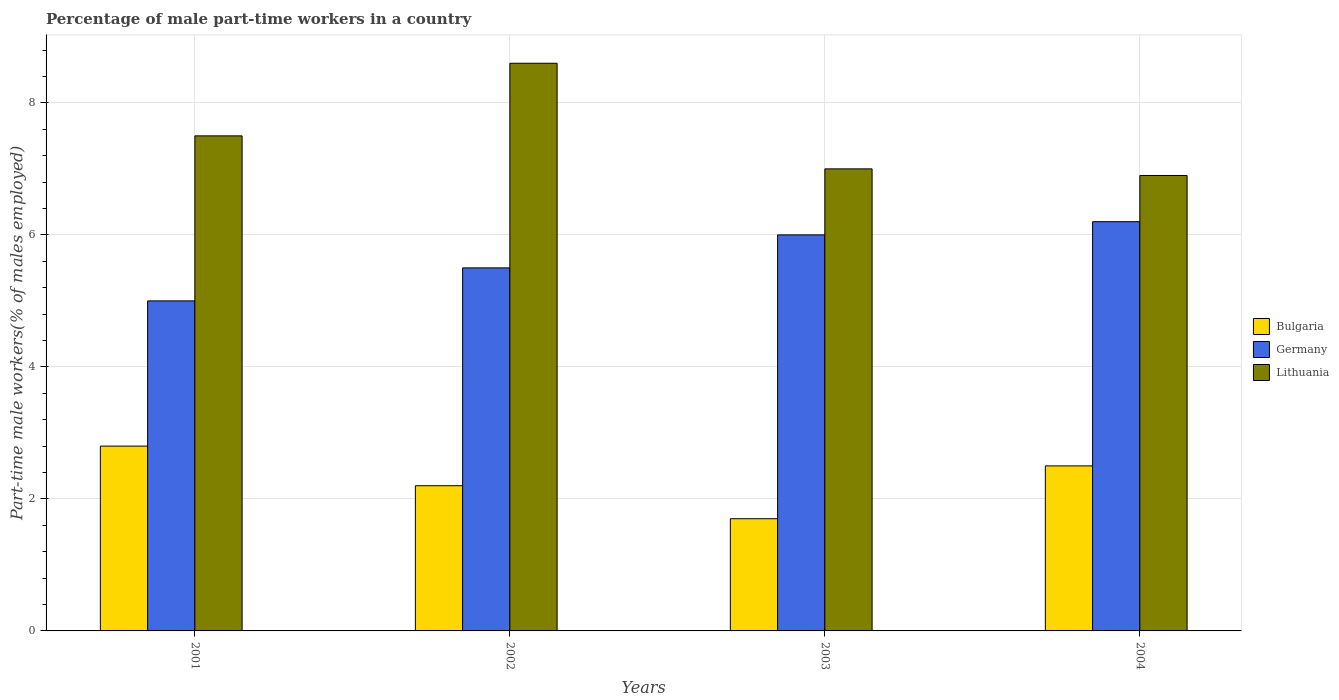How many different coloured bars are there?
Your answer should be very brief. 3. How many groups of bars are there?
Keep it short and to the point. 4. Are the number of bars per tick equal to the number of legend labels?
Give a very brief answer. Yes. Are the number of bars on each tick of the X-axis equal?
Offer a very short reply. Yes. How many bars are there on the 3rd tick from the left?
Make the answer very short. 3. In how many cases, is the number of bars for a given year not equal to the number of legend labels?
Your answer should be compact. 0. What is the percentage of male part-time workers in Bulgaria in 2002?
Make the answer very short. 2.2. Across all years, what is the maximum percentage of male part-time workers in Germany?
Your answer should be compact. 6.2. Across all years, what is the minimum percentage of male part-time workers in Lithuania?
Provide a succinct answer. 6.9. In which year was the percentage of male part-time workers in Germany maximum?
Your answer should be compact. 2004. In which year was the percentage of male part-time workers in Bulgaria minimum?
Offer a very short reply. 2003. What is the total percentage of male part-time workers in Germany in the graph?
Your answer should be compact. 22.7. What is the difference between the percentage of male part-time workers in Germany in 2003 and that in 2004?
Ensure brevity in your answer.  -0.2. What is the difference between the percentage of male part-time workers in Lithuania in 2002 and the percentage of male part-time workers in Germany in 2004?
Provide a short and direct response. 2.4. What is the average percentage of male part-time workers in Lithuania per year?
Your answer should be compact. 7.5. In the year 2003, what is the difference between the percentage of male part-time workers in Lithuania and percentage of male part-time workers in Bulgaria?
Provide a short and direct response. 5.3. In how many years, is the percentage of male part-time workers in Lithuania greater than 2.8 %?
Provide a short and direct response. 4. What is the ratio of the percentage of male part-time workers in Lithuania in 2001 to that in 2004?
Ensure brevity in your answer.  1.09. Is the difference between the percentage of male part-time workers in Lithuania in 2001 and 2004 greater than the difference between the percentage of male part-time workers in Bulgaria in 2001 and 2004?
Your response must be concise. Yes. What is the difference between the highest and the second highest percentage of male part-time workers in Bulgaria?
Make the answer very short. 0.3. What is the difference between the highest and the lowest percentage of male part-time workers in Lithuania?
Make the answer very short. 1.7. Is the sum of the percentage of male part-time workers in Lithuania in 2001 and 2004 greater than the maximum percentage of male part-time workers in Bulgaria across all years?
Make the answer very short. Yes. What does the 3rd bar from the left in 2002 represents?
Your answer should be very brief. Lithuania. What does the 1st bar from the right in 2001 represents?
Make the answer very short. Lithuania. Is it the case that in every year, the sum of the percentage of male part-time workers in Bulgaria and percentage of male part-time workers in Germany is greater than the percentage of male part-time workers in Lithuania?
Offer a terse response. No. How many bars are there?
Your answer should be very brief. 12. Are all the bars in the graph horizontal?
Give a very brief answer. No. How many years are there in the graph?
Your answer should be very brief. 4. What is the difference between two consecutive major ticks on the Y-axis?
Your answer should be compact. 2. Are the values on the major ticks of Y-axis written in scientific E-notation?
Offer a very short reply. No. Does the graph contain any zero values?
Ensure brevity in your answer.  No. What is the title of the graph?
Your answer should be very brief. Percentage of male part-time workers in a country. What is the label or title of the Y-axis?
Make the answer very short. Part-time male workers(% of males employed). What is the Part-time male workers(% of males employed) of Bulgaria in 2001?
Your answer should be compact. 2.8. What is the Part-time male workers(% of males employed) in Bulgaria in 2002?
Provide a succinct answer. 2.2. What is the Part-time male workers(% of males employed) of Germany in 2002?
Provide a succinct answer. 5.5. What is the Part-time male workers(% of males employed) in Lithuania in 2002?
Keep it short and to the point. 8.6. What is the Part-time male workers(% of males employed) in Bulgaria in 2003?
Your answer should be compact. 1.7. What is the Part-time male workers(% of males employed) in Germany in 2003?
Offer a terse response. 6. What is the Part-time male workers(% of males employed) of Germany in 2004?
Your answer should be very brief. 6.2. What is the Part-time male workers(% of males employed) of Lithuania in 2004?
Ensure brevity in your answer.  6.9. Across all years, what is the maximum Part-time male workers(% of males employed) of Bulgaria?
Offer a very short reply. 2.8. Across all years, what is the maximum Part-time male workers(% of males employed) of Germany?
Offer a very short reply. 6.2. Across all years, what is the maximum Part-time male workers(% of males employed) of Lithuania?
Your response must be concise. 8.6. Across all years, what is the minimum Part-time male workers(% of males employed) of Bulgaria?
Your answer should be compact. 1.7. Across all years, what is the minimum Part-time male workers(% of males employed) in Lithuania?
Your response must be concise. 6.9. What is the total Part-time male workers(% of males employed) of Germany in the graph?
Keep it short and to the point. 22.7. What is the total Part-time male workers(% of males employed) of Lithuania in the graph?
Keep it short and to the point. 30. What is the difference between the Part-time male workers(% of males employed) of Germany in 2001 and that in 2002?
Your answer should be compact. -0.5. What is the difference between the Part-time male workers(% of males employed) of Lithuania in 2001 and that in 2002?
Keep it short and to the point. -1.1. What is the difference between the Part-time male workers(% of males employed) of Germany in 2001 and that in 2003?
Ensure brevity in your answer.  -1. What is the difference between the Part-time male workers(% of males employed) in Lithuania in 2001 and that in 2003?
Make the answer very short. 0.5. What is the difference between the Part-time male workers(% of males employed) in Germany in 2001 and that in 2004?
Give a very brief answer. -1.2. What is the difference between the Part-time male workers(% of males employed) in Lithuania in 2002 and that in 2004?
Keep it short and to the point. 1.7. What is the difference between the Part-time male workers(% of males employed) of Germany in 2003 and that in 2004?
Offer a terse response. -0.2. What is the difference between the Part-time male workers(% of males employed) of Lithuania in 2003 and that in 2004?
Give a very brief answer. 0.1. What is the difference between the Part-time male workers(% of males employed) in Bulgaria in 2001 and the Part-time male workers(% of males employed) in Lithuania in 2002?
Ensure brevity in your answer.  -5.8. What is the difference between the Part-time male workers(% of males employed) in Germany in 2001 and the Part-time male workers(% of males employed) in Lithuania in 2002?
Give a very brief answer. -3.6. What is the difference between the Part-time male workers(% of males employed) in Bulgaria in 2001 and the Part-time male workers(% of males employed) in Germany in 2003?
Make the answer very short. -3.2. What is the difference between the Part-time male workers(% of males employed) in Germany in 2001 and the Part-time male workers(% of males employed) in Lithuania in 2003?
Make the answer very short. -2. What is the difference between the Part-time male workers(% of males employed) of Bulgaria in 2001 and the Part-time male workers(% of males employed) of Germany in 2004?
Give a very brief answer. -3.4. What is the difference between the Part-time male workers(% of males employed) in Bulgaria in 2002 and the Part-time male workers(% of males employed) in Germany in 2003?
Offer a terse response. -3.8. What is the difference between the Part-time male workers(% of males employed) of Germany in 2002 and the Part-time male workers(% of males employed) of Lithuania in 2003?
Make the answer very short. -1.5. What is the difference between the Part-time male workers(% of males employed) of Bulgaria in 2002 and the Part-time male workers(% of males employed) of Germany in 2004?
Provide a short and direct response. -4. What is the difference between the Part-time male workers(% of males employed) in Bulgaria in 2002 and the Part-time male workers(% of males employed) in Lithuania in 2004?
Ensure brevity in your answer.  -4.7. What is the difference between the Part-time male workers(% of males employed) of Bulgaria in 2003 and the Part-time male workers(% of males employed) of Germany in 2004?
Keep it short and to the point. -4.5. What is the difference between the Part-time male workers(% of males employed) of Germany in 2003 and the Part-time male workers(% of males employed) of Lithuania in 2004?
Provide a short and direct response. -0.9. What is the average Part-time male workers(% of males employed) of Germany per year?
Your answer should be compact. 5.67. What is the average Part-time male workers(% of males employed) of Lithuania per year?
Your answer should be very brief. 7.5. In the year 2002, what is the difference between the Part-time male workers(% of males employed) of Bulgaria and Part-time male workers(% of males employed) of Lithuania?
Ensure brevity in your answer.  -6.4. In the year 2003, what is the difference between the Part-time male workers(% of males employed) of Bulgaria and Part-time male workers(% of males employed) of Germany?
Ensure brevity in your answer.  -4.3. In the year 2003, what is the difference between the Part-time male workers(% of males employed) in Bulgaria and Part-time male workers(% of males employed) in Lithuania?
Provide a short and direct response. -5.3. What is the ratio of the Part-time male workers(% of males employed) of Bulgaria in 2001 to that in 2002?
Provide a succinct answer. 1.27. What is the ratio of the Part-time male workers(% of males employed) of Germany in 2001 to that in 2002?
Provide a succinct answer. 0.91. What is the ratio of the Part-time male workers(% of males employed) in Lithuania in 2001 to that in 2002?
Your answer should be very brief. 0.87. What is the ratio of the Part-time male workers(% of males employed) in Bulgaria in 2001 to that in 2003?
Offer a very short reply. 1.65. What is the ratio of the Part-time male workers(% of males employed) in Germany in 2001 to that in 2003?
Your response must be concise. 0.83. What is the ratio of the Part-time male workers(% of males employed) of Lithuania in 2001 to that in 2003?
Your response must be concise. 1.07. What is the ratio of the Part-time male workers(% of males employed) of Bulgaria in 2001 to that in 2004?
Your answer should be compact. 1.12. What is the ratio of the Part-time male workers(% of males employed) in Germany in 2001 to that in 2004?
Ensure brevity in your answer.  0.81. What is the ratio of the Part-time male workers(% of males employed) in Lithuania in 2001 to that in 2004?
Provide a short and direct response. 1.09. What is the ratio of the Part-time male workers(% of males employed) in Bulgaria in 2002 to that in 2003?
Your answer should be compact. 1.29. What is the ratio of the Part-time male workers(% of males employed) of Germany in 2002 to that in 2003?
Make the answer very short. 0.92. What is the ratio of the Part-time male workers(% of males employed) in Lithuania in 2002 to that in 2003?
Your answer should be very brief. 1.23. What is the ratio of the Part-time male workers(% of males employed) of Bulgaria in 2002 to that in 2004?
Offer a terse response. 0.88. What is the ratio of the Part-time male workers(% of males employed) of Germany in 2002 to that in 2004?
Keep it short and to the point. 0.89. What is the ratio of the Part-time male workers(% of males employed) in Lithuania in 2002 to that in 2004?
Your answer should be compact. 1.25. What is the ratio of the Part-time male workers(% of males employed) of Bulgaria in 2003 to that in 2004?
Your response must be concise. 0.68. What is the ratio of the Part-time male workers(% of males employed) of Germany in 2003 to that in 2004?
Your answer should be very brief. 0.97. What is the ratio of the Part-time male workers(% of males employed) of Lithuania in 2003 to that in 2004?
Your answer should be compact. 1.01. What is the difference between the highest and the second highest Part-time male workers(% of males employed) in Bulgaria?
Provide a short and direct response. 0.3. What is the difference between the highest and the second highest Part-time male workers(% of males employed) in Germany?
Provide a short and direct response. 0.2. What is the difference between the highest and the second highest Part-time male workers(% of males employed) of Lithuania?
Offer a very short reply. 1.1. What is the difference between the highest and the lowest Part-time male workers(% of males employed) in Lithuania?
Offer a very short reply. 1.7. 